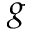Convert formula to latex. <formula><loc_0><loc_0><loc_500><loc_500>g</formula> 